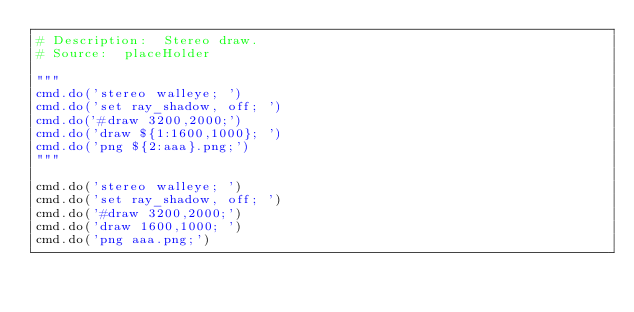Convert code to text. <code><loc_0><loc_0><loc_500><loc_500><_Python_># Description:  Stereo draw.
# Source:  placeHolder

"""
cmd.do('stereo walleye; ')
cmd.do('set ray_shadow, off; ')
cmd.do('#draw 3200,2000;')
cmd.do('draw ${1:1600,1000}; ')
cmd.do('png ${2:aaa}.png;')
"""

cmd.do('stereo walleye; ')
cmd.do('set ray_shadow, off; ')
cmd.do('#draw 3200,2000;')
cmd.do('draw 1600,1000; ')
cmd.do('png aaa.png;')
</code> 